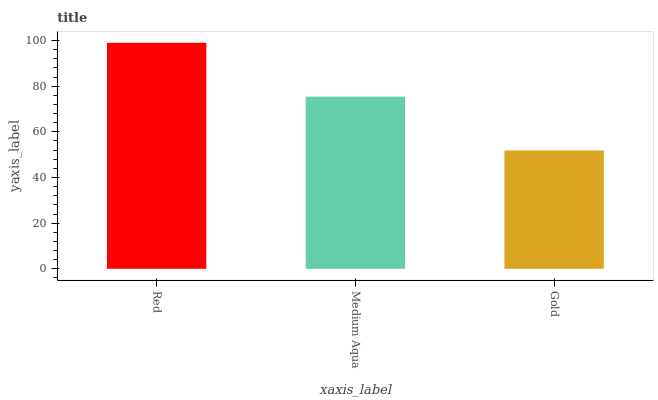Is Medium Aqua the minimum?
Answer yes or no. No. Is Medium Aqua the maximum?
Answer yes or no. No. Is Red greater than Medium Aqua?
Answer yes or no. Yes. Is Medium Aqua less than Red?
Answer yes or no. Yes. Is Medium Aqua greater than Red?
Answer yes or no. No. Is Red less than Medium Aqua?
Answer yes or no. No. Is Medium Aqua the high median?
Answer yes or no. Yes. Is Medium Aqua the low median?
Answer yes or no. Yes. Is Gold the high median?
Answer yes or no. No. Is Gold the low median?
Answer yes or no. No. 